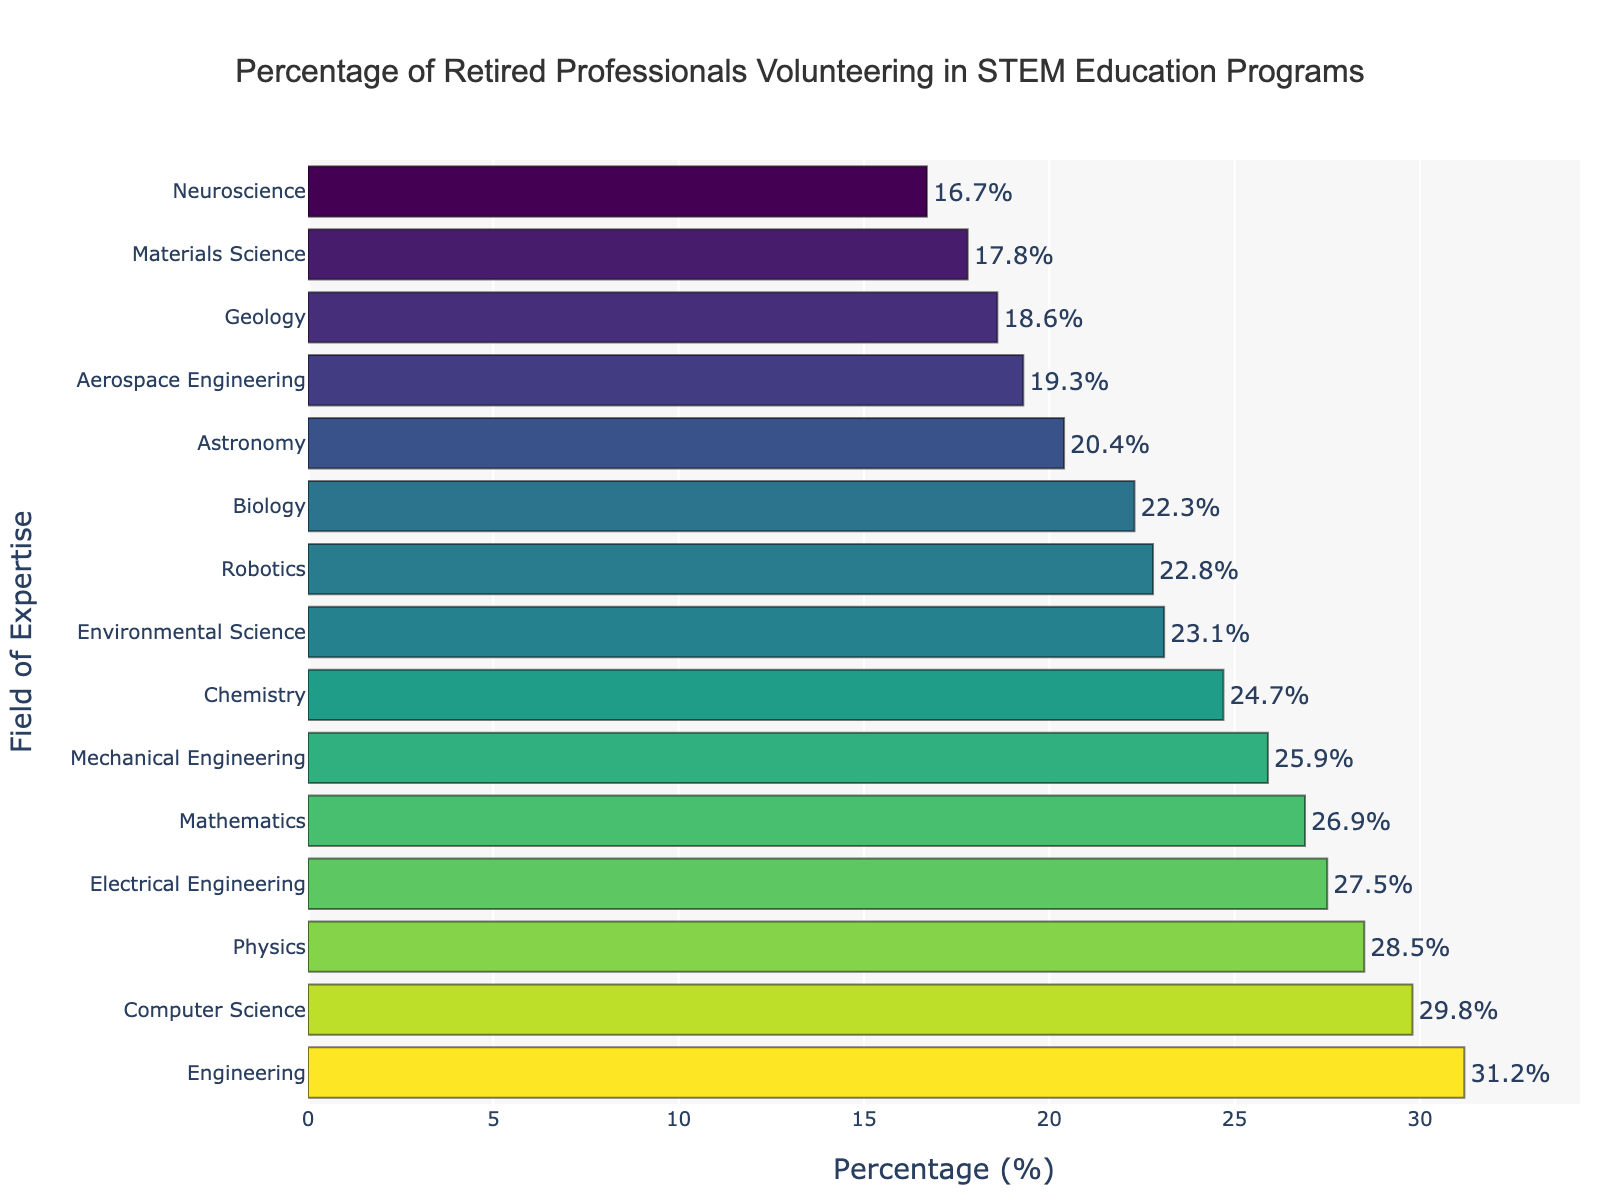Which field has the highest percentage of retired professionals volunteering in STEM education programs? The bar for Engineering is the longest, indicating it has the highest percentage.
Answer: Engineering Which two fields have the closest percentages of volunteering retired professionals? Compare the lengths of all bars. Physics (28.5%) and Electrical Engineering (27.5%) have percentages closest to each other.
Answer: Physics and Electrical Engineering What is the difference in percentage between the field with the highest and the field with the lowest volunteering rates? The highest percentage is Engineering (31.2%) and the lowest is Neuroscience (16.7%), so the difference is 31.2 - 16.7 = 14.5%.
Answer: 14.5% How does the volunteering percentage in Computer Science compare to Mathematics? Computer Science has a percentage of 29.8%, which is higher than Mathematics at 26.9%.
Answer: Computer Science is higher Is the percentage for Environmental Science greater or less than the average percentage across all fields? Calculate the average: (28.5 + 24.7 + 22.3 + 31.2 + 26.9 + 29.8 + 18.6 + 20.4 + 23.1 + 17.8 + 27.5 + 25.9 + 19.3 + 16.7 + 22.8) / 15 ≈ 23.6%. Environmental Science has 23.1%, which is less.
Answer: Less If you combine the percentages of Chemistry and Biology, which field's volunteering percentage is closest to this sum? Chemistry (24.7%) + Biology (22.3%) = 47%. This is closest to Computer Science (29.8%) and Engineering (31.2%) when combined with another field's percentage.
Answer: None of the fields individually Which field has a nearly average percentage of retired volunteers? The average percentage is approximately 23.6%. Biology at 22.3% is quite close to this average.
Answer: Biology How does the volunteering percentage in Aerospace Engineering compare to Geology? Aerospace Engineering has a percentage of 19.3%, which is slightly higher than Geology at 18.6%.
Answer: Aerospace Engineering is higher What is the range of percentages for all fields? The range is calculated by subtracting the minimum percentage (Neuroscience, 16.7%) from the maximum percentage (Engineering, 31.2%). Thus, the range is 31.2 - 16.7 = 14.5%.
Answer: 14.5% Which fields have a volunteering percentage above 25%? Physics (28.5%), Engineering (31.2%), Computer Science (29.8%), Mathematics (26.9%), Electrical Engineering (27.5%), and Mechanical Engineering (25.9%) all have percentages above 25%.
Answer: Physics, Engineering, Computer Science, Mathematics, Electrical Engineering, Mechanical Engineering 